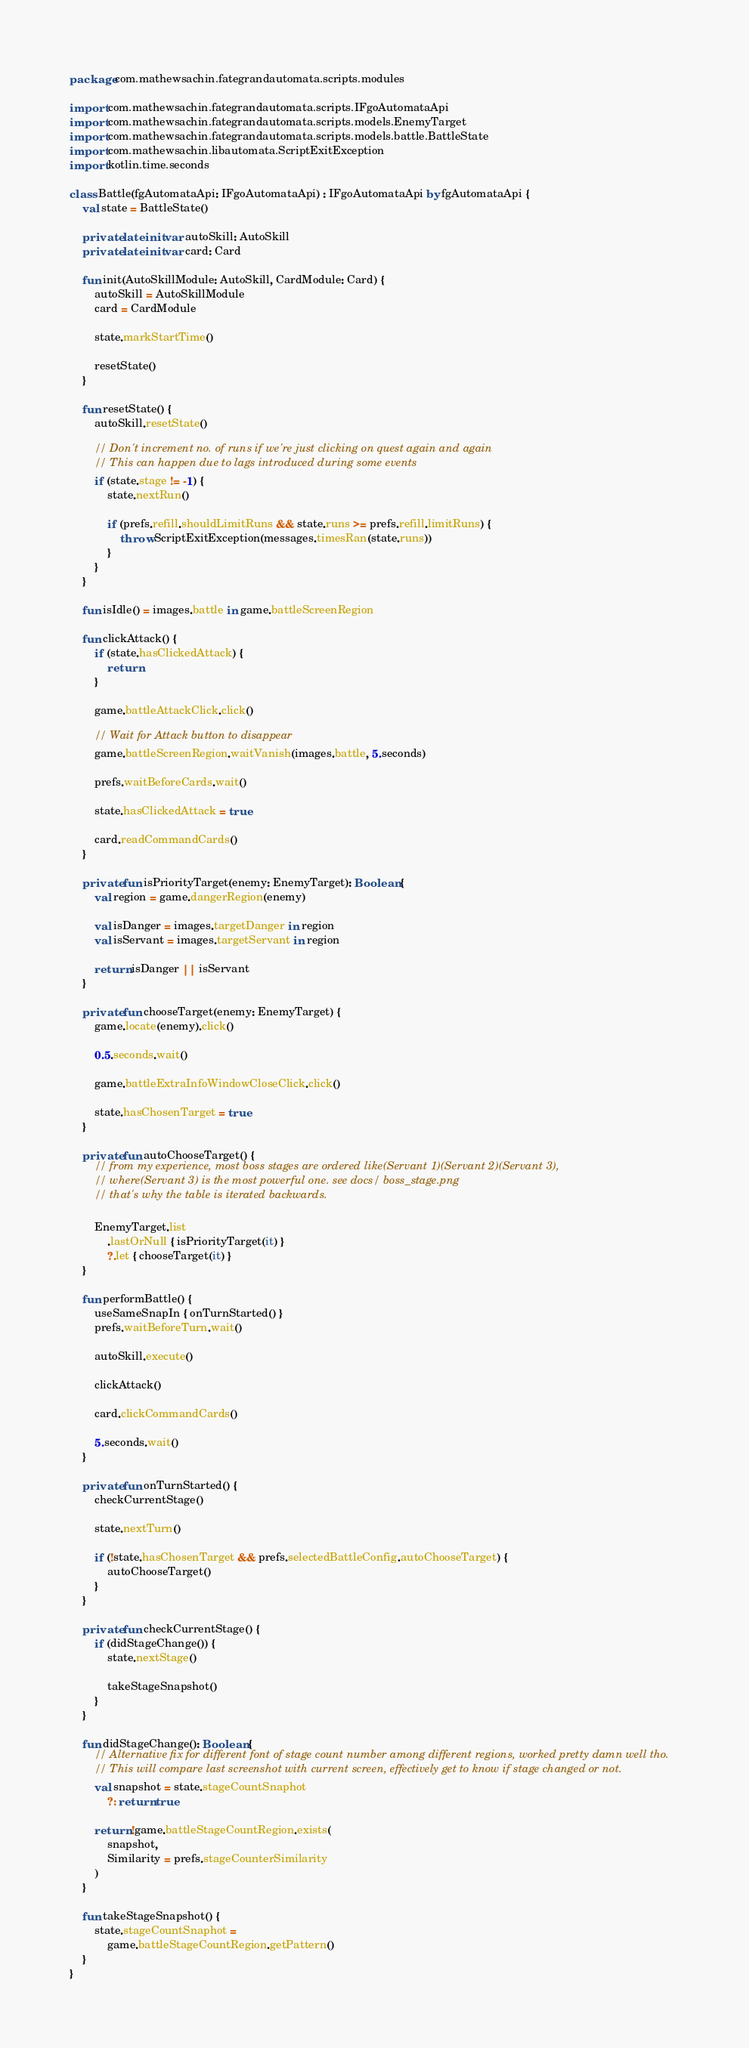Convert code to text. <code><loc_0><loc_0><loc_500><loc_500><_Kotlin_>package com.mathewsachin.fategrandautomata.scripts.modules

import com.mathewsachin.fategrandautomata.scripts.IFgoAutomataApi
import com.mathewsachin.fategrandautomata.scripts.models.EnemyTarget
import com.mathewsachin.fategrandautomata.scripts.models.battle.BattleState
import com.mathewsachin.libautomata.ScriptExitException
import kotlin.time.seconds

class Battle(fgAutomataApi: IFgoAutomataApi) : IFgoAutomataApi by fgAutomataApi {
    val state = BattleState()

    private lateinit var autoSkill: AutoSkill
    private lateinit var card: Card

    fun init(AutoSkillModule: AutoSkill, CardModule: Card) {
        autoSkill = AutoSkillModule
        card = CardModule

        state.markStartTime()

        resetState()
    }

    fun resetState() {
        autoSkill.resetState()

        // Don't increment no. of runs if we're just clicking on quest again and again
        // This can happen due to lags introduced during some events
        if (state.stage != -1) {
            state.nextRun()

            if (prefs.refill.shouldLimitRuns && state.runs >= prefs.refill.limitRuns) {
                throw ScriptExitException(messages.timesRan(state.runs))
            }
        }
    }

    fun isIdle() = images.battle in game.battleScreenRegion

    fun clickAttack() {
        if (state.hasClickedAttack) {
            return
        }

        game.battleAttackClick.click()

        // Wait for Attack button to disappear
        game.battleScreenRegion.waitVanish(images.battle, 5.seconds)

        prefs.waitBeforeCards.wait()

        state.hasClickedAttack = true

        card.readCommandCards()
    }

    private fun isPriorityTarget(enemy: EnemyTarget): Boolean {
        val region = game.dangerRegion(enemy)

        val isDanger = images.targetDanger in region
        val isServant = images.targetServant in region

        return isDanger || isServant
    }

    private fun chooseTarget(enemy: EnemyTarget) {
        game.locate(enemy).click()

        0.5.seconds.wait()

        game.battleExtraInfoWindowCloseClick.click()

        state.hasChosenTarget = true
    }

    private fun autoChooseTarget() {
        // from my experience, most boss stages are ordered like(Servant 1)(Servant 2)(Servant 3),
        // where(Servant 3) is the most powerful one. see docs/ boss_stage.png
        // that's why the table is iterated backwards.

        EnemyTarget.list
            .lastOrNull { isPriorityTarget(it) }
            ?.let { chooseTarget(it) }
    }

    fun performBattle() {
        useSameSnapIn { onTurnStarted() }
        prefs.waitBeforeTurn.wait()

        autoSkill.execute()

        clickAttack()

        card.clickCommandCards()

        5.seconds.wait()
    }

    private fun onTurnStarted() {
        checkCurrentStage()

        state.nextTurn()

        if (!state.hasChosenTarget && prefs.selectedBattleConfig.autoChooseTarget) {
            autoChooseTarget()
        }
    }

    private fun checkCurrentStage() {
        if (didStageChange()) {
            state.nextStage()

            takeStageSnapshot()
        }
    }

    fun didStageChange(): Boolean {
        // Alternative fix for different font of stage count number among different regions, worked pretty damn well tho.
        // This will compare last screenshot with current screen, effectively get to know if stage changed or not.
        val snapshot = state.stageCountSnaphot
            ?: return true

        return !game.battleStageCountRegion.exists(
            snapshot,
            Similarity = prefs.stageCounterSimilarity
        )
    }

    fun takeStageSnapshot() {
        state.stageCountSnaphot =
            game.battleStageCountRegion.getPattern()
    }
}
</code> 